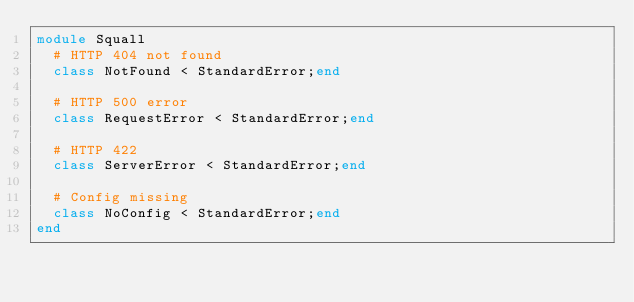<code> <loc_0><loc_0><loc_500><loc_500><_Ruby_>module Squall
  # HTTP 404 not found
  class NotFound < StandardError;end

  # HTTP 500 error
  class RequestError < StandardError;end

  # HTTP 422
  class ServerError < StandardError;end

  # Config missing
  class NoConfig < StandardError;end
end
</code> 